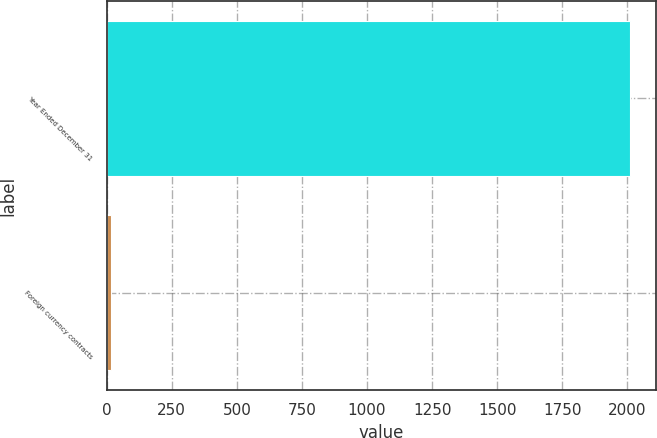<chart> <loc_0><loc_0><loc_500><loc_500><bar_chart><fcel>Year Ended December 31<fcel>Foreign currency contracts<nl><fcel>2010<fcel>15<nl></chart> 